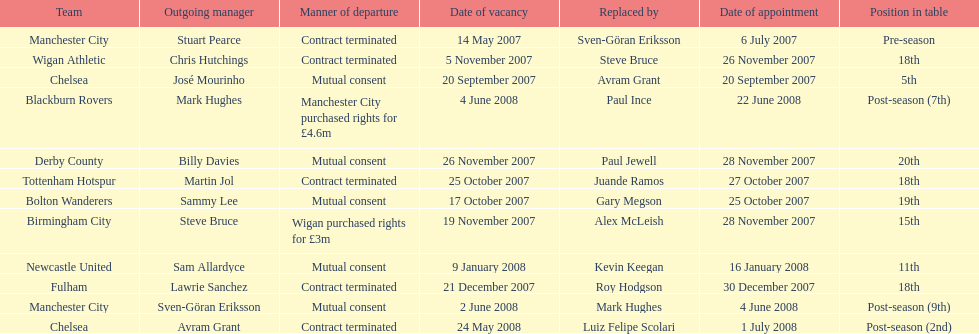How many teams had a manner of departure due to there contract being terminated? 5. 